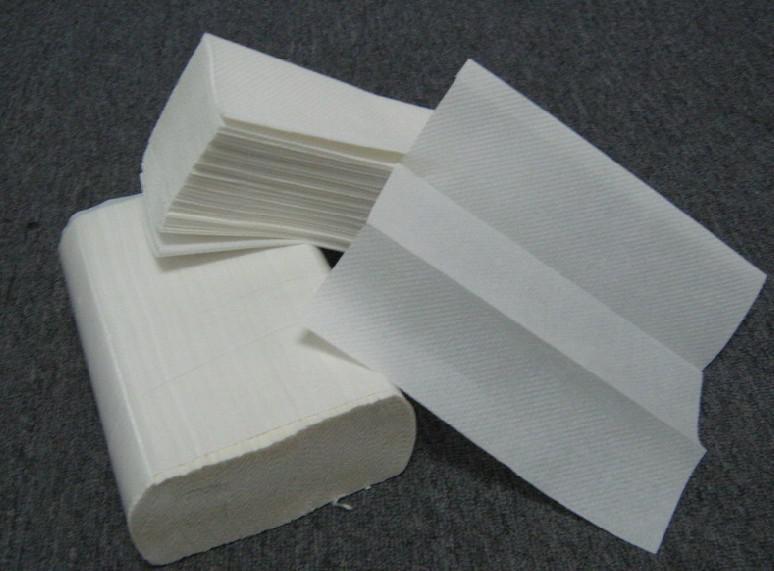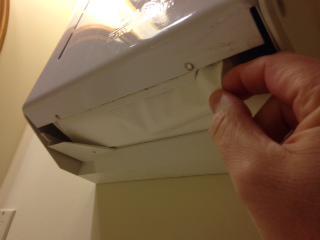The first image is the image on the left, the second image is the image on the right. Considering the images on both sides, is "A human hand is partially visible in the right image." valid? Answer yes or no. Yes. 